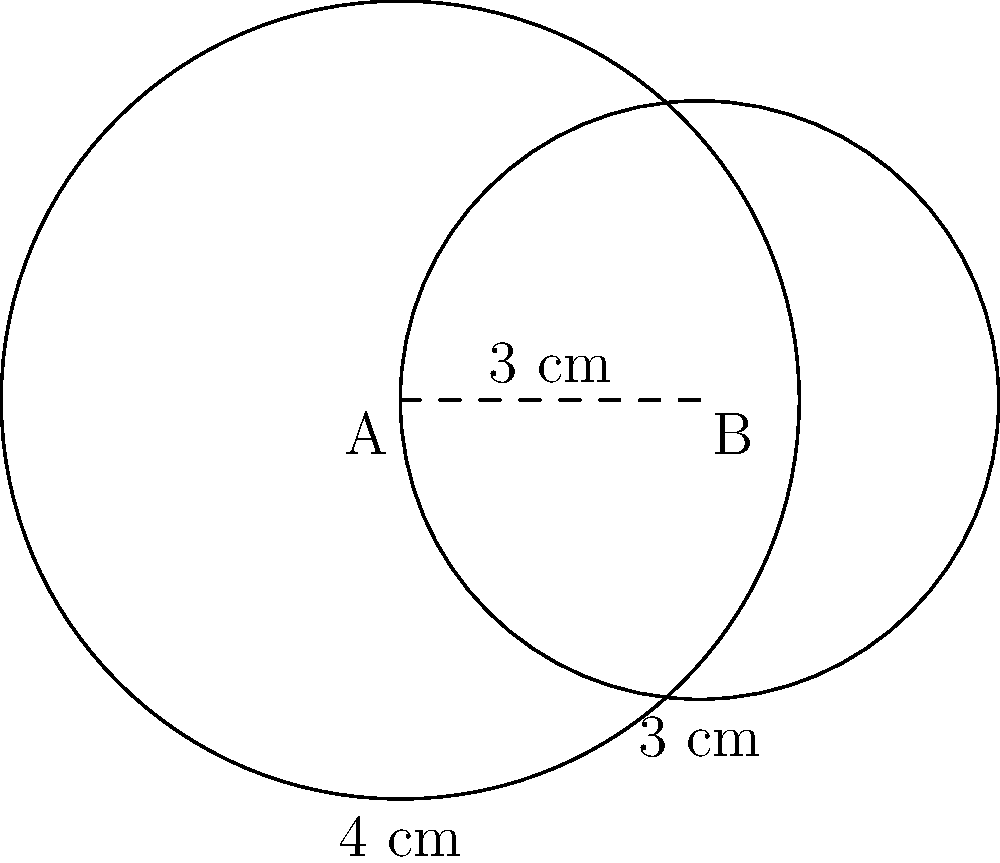You are designing a wooden panel with two circular openings for a custom electronic enclosure. The centers of the circles are 3 cm apart, and their radii are 4 cm and 3 cm, respectively. Calculate the area of the overlapping region between the two circular openings. To find the area of overlap between two circles, we can use the formula for the area of intersection:

$$A = r_1^2 \arccos(\frac{d^2 + r_1^2 - r_2^2}{2dr_1}) + r_2^2 \arccos(\frac{d^2 + r_2^2 - r_1^2}{2dr_2}) - \frac{1}{2}\sqrt{(-d+r_1+r_2)(d+r_1-r_2)(d-r_1+r_2)(d+r_1+r_2)}$$

Where:
$r_1 = 4$ cm (radius of the larger circle)
$r_2 = 3$ cm (radius of the smaller circle)
$d = 3$ cm (distance between centers)

Step 1: Calculate the first term
$$r_1^2 \arccos(\frac{d^2 + r_1^2 - r_2^2}{2dr_1}) = 16 \arccos(\frac{9 + 16 - 9}{2 \cdot 3 \cdot 4}) = 16 \arccos(\frac{16}{24}) \approx 10.47$$

Step 2: Calculate the second term
$$r_2^2 \arccos(\frac{d^2 + r_2^2 - r_1^2}{2dr_2}) = 9 \arccos(\frac{9 + 9 - 16}{2 \cdot 3 \cdot 3}) = 9 \arccos(\frac{2}{18}) \approx 13.46$$

Step 3: Calculate the third term
$$\frac{1}{2}\sqrt{(-d+r_1+r_2)(d+r_1-r_2)(d-r_1+r_2)(d+r_1+r_2)}$$
$$= \frac{1}{2}\sqrt{(-3+4+3)(3+4-3)(3-4+3)(3+4+3)} = \frac{1}{2}\sqrt{4 \cdot 4 \cdot 2 \cdot 10} = \sqrt{160} \approx 12.65$$

Step 4: Sum up the results
$$A = 10.47 + 13.46 - 12.65 \approx 11.28\text{ cm}^2$$

Therefore, the area of the overlapping region is approximately 11.28 square centimeters.
Answer: 11.28 cm² 